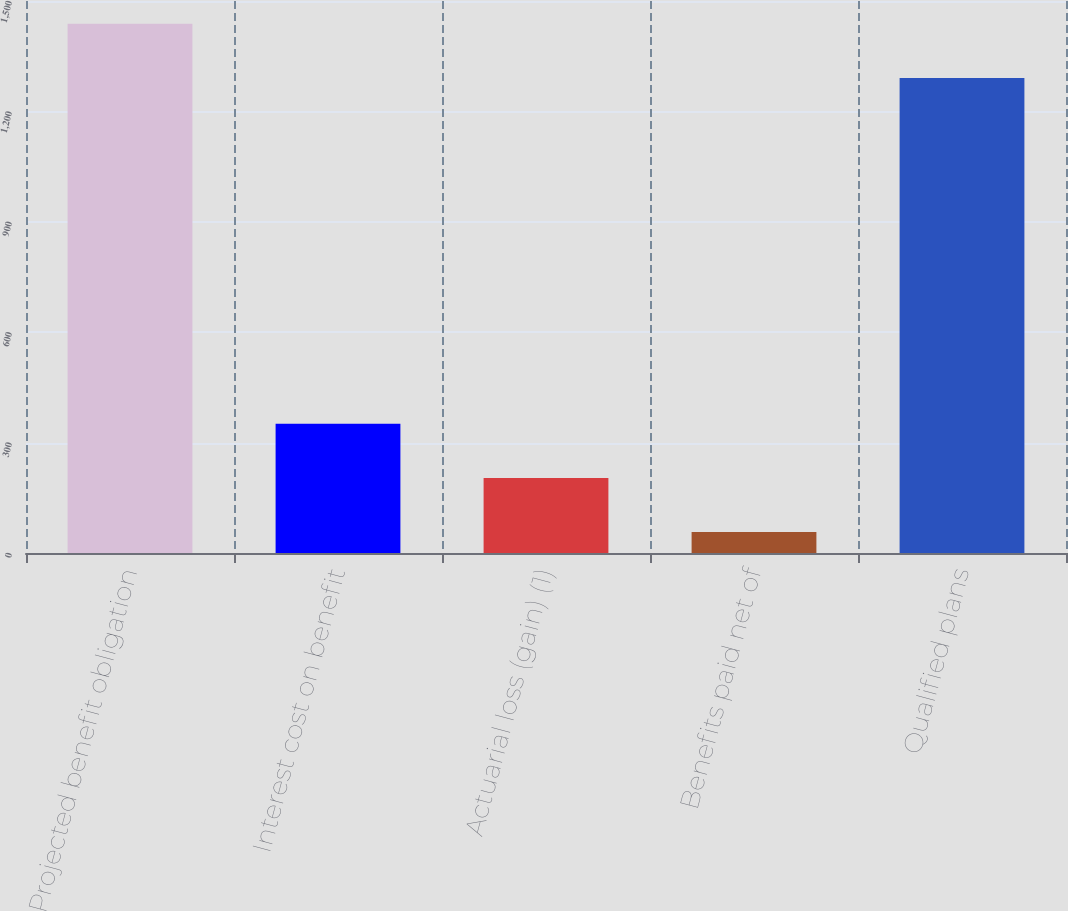Convert chart to OTSL. <chart><loc_0><loc_0><loc_500><loc_500><bar_chart><fcel>Projected benefit obligation<fcel>Interest cost on benefit<fcel>Actuarial loss (gain) (1)<fcel>Benefits paid net of<fcel>Qualified plans<nl><fcel>1438<fcel>351<fcel>204<fcel>57<fcel>1291<nl></chart> 